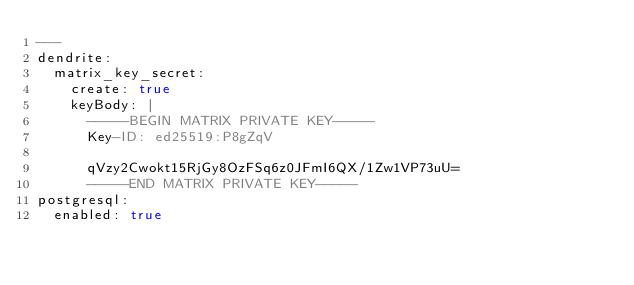Convert code to text. <code><loc_0><loc_0><loc_500><loc_500><_YAML_>---
dendrite:
  matrix_key_secret:
    create: true
    keyBody: |
      -----BEGIN MATRIX PRIVATE KEY-----
      Key-ID: ed25519:P8gZqV

      qVzy2Cwokt15RjGy8OzFSq6z0JFmI6QX/1Zw1VP73uU=
      -----END MATRIX PRIVATE KEY-----
postgresql:
  enabled: true
</code> 